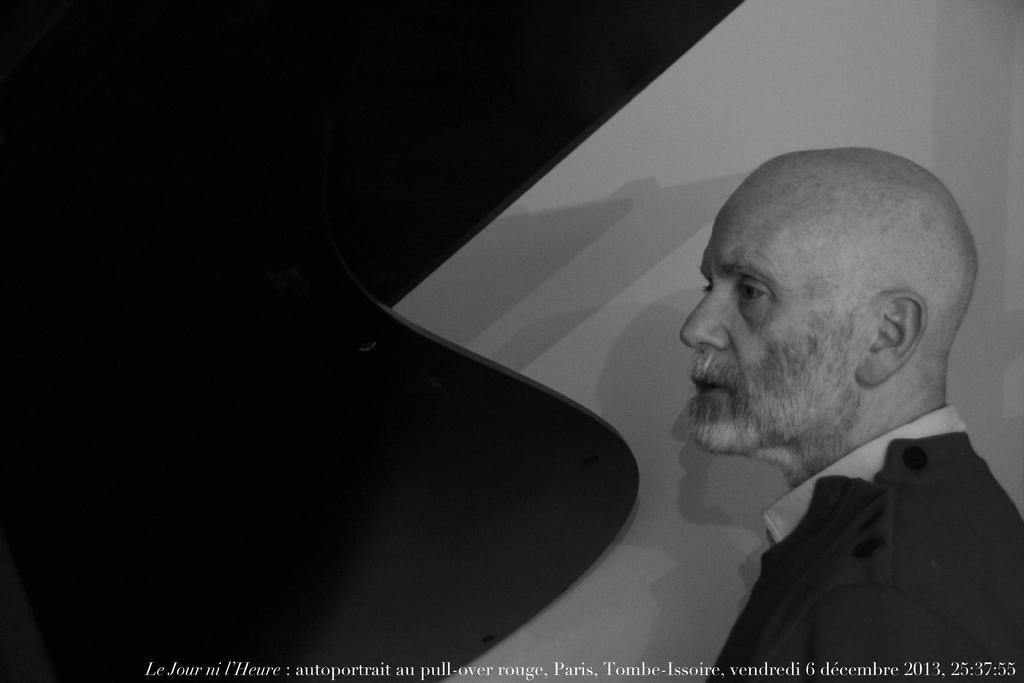Could you give a brief overview of what you see in this image? This is a black and white image. In the image we can see a man wearing clothes. At the bottom we can see the watermark. 